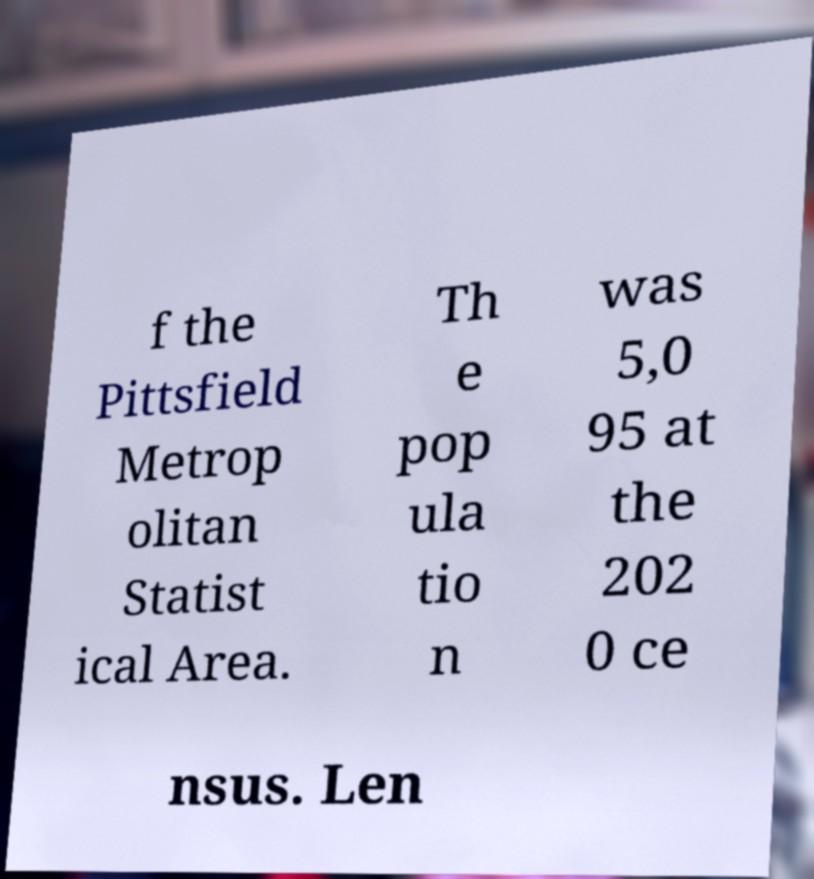Please read and relay the text visible in this image. What does it say? f the Pittsfield Metrop olitan Statist ical Area. Th e pop ula tio n was 5,0 95 at the 202 0 ce nsus. Len 